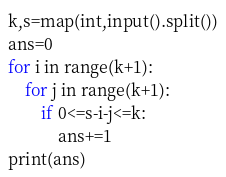Convert code to text. <code><loc_0><loc_0><loc_500><loc_500><_Python_>k,s=map(int,input().split())
ans=0
for i in range(k+1):
    for j in range(k+1):
        if 0<=s-i-j<=k:
            ans+=1
print(ans) </code> 